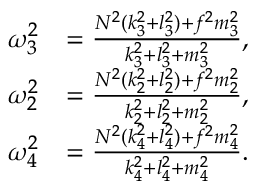Convert formula to latex. <formula><loc_0><loc_0><loc_500><loc_500>\begin{array} { r l } { \omega _ { 3 } ^ { 2 } } & { = \frac { N ^ { 2 } ( k _ { 3 } ^ { 2 } + l _ { 3 } ^ { 2 } ) + f ^ { 2 } m _ { 3 } ^ { 2 } } { k _ { 3 } ^ { 2 } + l _ { 3 } ^ { 2 } + m _ { 3 } ^ { 2 } } , } \\ { \omega _ { 2 } ^ { 2 } } & { = \frac { N ^ { 2 } ( k _ { 2 } ^ { 2 } + l _ { 2 } ^ { 2 } ) + f ^ { 2 } m _ { 2 } ^ { 2 } } { k _ { 2 } ^ { 2 } + l _ { 2 } ^ { 2 } + m _ { 2 } ^ { 2 } } , } \\ { \omega _ { 4 } ^ { 2 } } & { = \frac { N ^ { 2 } ( k _ { 4 } ^ { 2 } + l _ { 4 } ^ { 2 } ) + f ^ { 2 } m _ { 4 } ^ { 2 } } { k _ { 4 } ^ { 2 } + l _ { 4 } ^ { 2 } + m _ { 4 } ^ { 2 } } . } \end{array}</formula> 